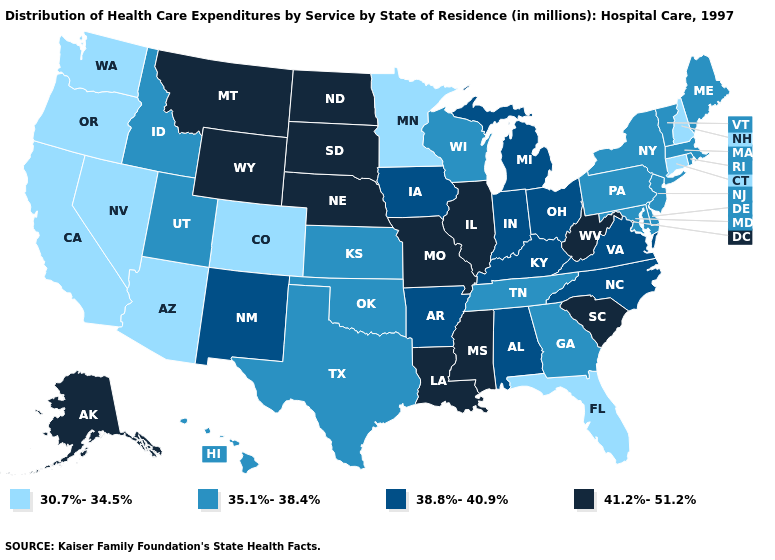Among the states that border Washington , does Oregon have the highest value?
Answer briefly. No. What is the value of Missouri?
Quick response, please. 41.2%-51.2%. Which states have the lowest value in the West?
Quick response, please. Arizona, California, Colorado, Nevada, Oregon, Washington. What is the value of Indiana?
Concise answer only. 38.8%-40.9%. What is the lowest value in the West?
Give a very brief answer. 30.7%-34.5%. Does Michigan have the same value as North Dakota?
Short answer required. No. Does Maine have the same value as Vermont?
Keep it brief. Yes. Does Delaware have the same value as Texas?
Short answer required. Yes. Does Wisconsin have the lowest value in the MidWest?
Short answer required. No. Name the states that have a value in the range 35.1%-38.4%?
Short answer required. Delaware, Georgia, Hawaii, Idaho, Kansas, Maine, Maryland, Massachusetts, New Jersey, New York, Oklahoma, Pennsylvania, Rhode Island, Tennessee, Texas, Utah, Vermont, Wisconsin. Name the states that have a value in the range 30.7%-34.5%?
Keep it brief. Arizona, California, Colorado, Connecticut, Florida, Minnesota, Nevada, New Hampshire, Oregon, Washington. What is the highest value in the West ?
Short answer required. 41.2%-51.2%. Does Wyoming have the highest value in the West?
Keep it brief. Yes. What is the value of Vermont?
Write a very short answer. 35.1%-38.4%. 